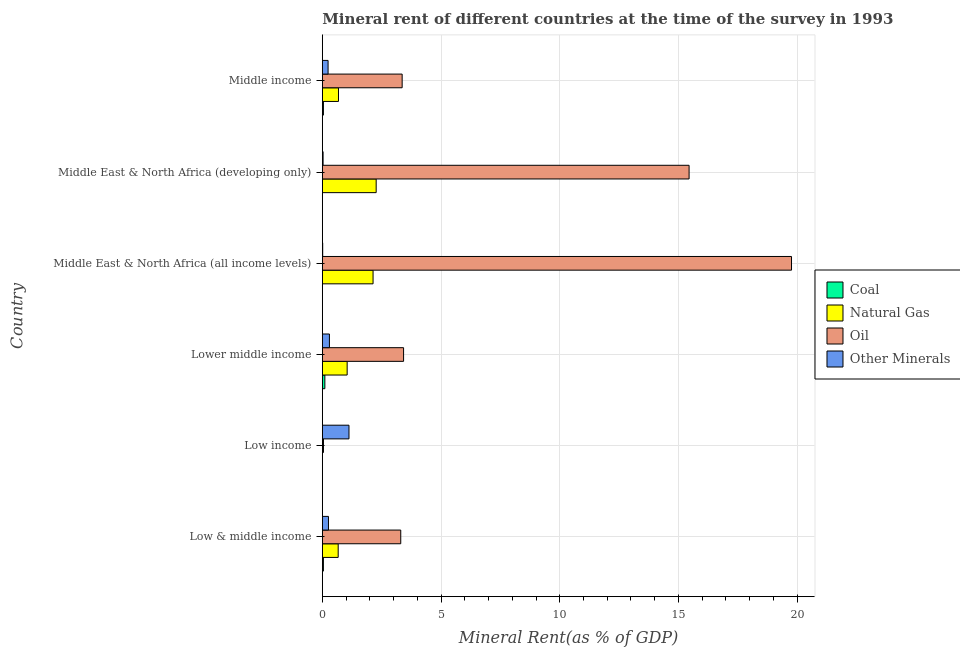How many different coloured bars are there?
Keep it short and to the point. 4. Are the number of bars on each tick of the Y-axis equal?
Give a very brief answer. Yes. How many bars are there on the 4th tick from the top?
Ensure brevity in your answer.  4. What is the label of the 1st group of bars from the top?
Give a very brief answer. Middle income. What is the  rent of other minerals in Middle East & North Africa (developing only)?
Your answer should be compact. 0.03. Across all countries, what is the maximum natural gas rent?
Ensure brevity in your answer.  2.27. Across all countries, what is the minimum oil rent?
Your response must be concise. 0.05. What is the total  rent of other minerals in the graph?
Give a very brief answer. 1.97. What is the difference between the natural gas rent in Low & middle income and that in Low income?
Provide a short and direct response. 0.67. What is the difference between the natural gas rent in Middle income and the  rent of other minerals in Low & middle income?
Your answer should be very brief. 0.42. What is the average natural gas rent per country?
Give a very brief answer. 1.13. What is the difference between the oil rent and natural gas rent in Low income?
Provide a succinct answer. 0.05. In how many countries, is the oil rent greater than 9 %?
Offer a terse response. 2. What is the ratio of the coal rent in Low & middle income to that in Middle East & North Africa (all income levels)?
Your response must be concise. 78.76. Is the coal rent in Lower middle income less than that in Middle East & North Africa (developing only)?
Give a very brief answer. No. Is the difference between the coal rent in Middle East & North Africa (all income levels) and Middle East & North Africa (developing only) greater than the difference between the oil rent in Middle East & North Africa (all income levels) and Middle East & North Africa (developing only)?
Make the answer very short. No. What is the difference between the highest and the second highest oil rent?
Keep it short and to the point. 4.31. What is the difference between the highest and the lowest  rent of other minerals?
Your answer should be very brief. 1.11. What does the 4th bar from the top in Low & middle income represents?
Make the answer very short. Coal. What does the 4th bar from the bottom in Middle East & North Africa (developing only) represents?
Make the answer very short. Other Minerals. Is it the case that in every country, the sum of the coal rent and natural gas rent is greater than the oil rent?
Offer a very short reply. No. How many bars are there?
Provide a short and direct response. 24. Are all the bars in the graph horizontal?
Provide a succinct answer. Yes. What is the difference between two consecutive major ticks on the X-axis?
Make the answer very short. 5. Are the values on the major ticks of X-axis written in scientific E-notation?
Provide a succinct answer. No. Does the graph contain any zero values?
Your answer should be very brief. No. How many legend labels are there?
Provide a succinct answer. 4. What is the title of the graph?
Keep it short and to the point. Mineral rent of different countries at the time of the survey in 1993. What is the label or title of the X-axis?
Offer a terse response. Mineral Rent(as % of GDP). What is the Mineral Rent(as % of GDP) of Coal in Low & middle income?
Offer a terse response. 0.05. What is the Mineral Rent(as % of GDP) of Natural Gas in Low & middle income?
Offer a terse response. 0.67. What is the Mineral Rent(as % of GDP) of Oil in Low & middle income?
Provide a succinct answer. 3.3. What is the Mineral Rent(as % of GDP) in Other Minerals in Low & middle income?
Offer a terse response. 0.26. What is the Mineral Rent(as % of GDP) in Coal in Low income?
Your response must be concise. 8.23532495624202e-6. What is the Mineral Rent(as % of GDP) of Natural Gas in Low income?
Ensure brevity in your answer.  1.98169078129084e-5. What is the Mineral Rent(as % of GDP) in Oil in Low income?
Keep it short and to the point. 0.05. What is the Mineral Rent(as % of GDP) of Other Minerals in Low income?
Make the answer very short. 1.12. What is the Mineral Rent(as % of GDP) of Coal in Lower middle income?
Ensure brevity in your answer.  0.11. What is the Mineral Rent(as % of GDP) in Natural Gas in Lower middle income?
Provide a short and direct response. 1.05. What is the Mineral Rent(as % of GDP) in Oil in Lower middle income?
Give a very brief answer. 3.42. What is the Mineral Rent(as % of GDP) of Other Minerals in Lower middle income?
Give a very brief answer. 0.3. What is the Mineral Rent(as % of GDP) in Coal in Middle East & North Africa (all income levels)?
Offer a terse response. 0. What is the Mineral Rent(as % of GDP) in Natural Gas in Middle East & North Africa (all income levels)?
Your answer should be compact. 2.14. What is the Mineral Rent(as % of GDP) of Oil in Middle East & North Africa (all income levels)?
Offer a very short reply. 19.76. What is the Mineral Rent(as % of GDP) of Other Minerals in Middle East & North Africa (all income levels)?
Your answer should be very brief. 0.02. What is the Mineral Rent(as % of GDP) in Coal in Middle East & North Africa (developing only)?
Ensure brevity in your answer.  0. What is the Mineral Rent(as % of GDP) in Natural Gas in Middle East & North Africa (developing only)?
Offer a very short reply. 2.27. What is the Mineral Rent(as % of GDP) in Oil in Middle East & North Africa (developing only)?
Provide a succinct answer. 15.45. What is the Mineral Rent(as % of GDP) in Other Minerals in Middle East & North Africa (developing only)?
Give a very brief answer. 0.03. What is the Mineral Rent(as % of GDP) of Coal in Middle income?
Your answer should be compact. 0.05. What is the Mineral Rent(as % of GDP) in Natural Gas in Middle income?
Give a very brief answer. 0.68. What is the Mineral Rent(as % of GDP) in Oil in Middle income?
Ensure brevity in your answer.  3.36. What is the Mineral Rent(as % of GDP) in Other Minerals in Middle income?
Your answer should be compact. 0.24. Across all countries, what is the maximum Mineral Rent(as % of GDP) of Coal?
Offer a very short reply. 0.11. Across all countries, what is the maximum Mineral Rent(as % of GDP) of Natural Gas?
Provide a succinct answer. 2.27. Across all countries, what is the maximum Mineral Rent(as % of GDP) of Oil?
Offer a terse response. 19.76. Across all countries, what is the maximum Mineral Rent(as % of GDP) of Other Minerals?
Offer a terse response. 1.12. Across all countries, what is the minimum Mineral Rent(as % of GDP) of Coal?
Offer a terse response. 8.23532495624202e-6. Across all countries, what is the minimum Mineral Rent(as % of GDP) of Natural Gas?
Your answer should be very brief. 1.98169078129084e-5. Across all countries, what is the minimum Mineral Rent(as % of GDP) in Oil?
Provide a succinct answer. 0.05. Across all countries, what is the minimum Mineral Rent(as % of GDP) of Other Minerals?
Give a very brief answer. 0.02. What is the total Mineral Rent(as % of GDP) in Coal in the graph?
Offer a very short reply. 0.2. What is the total Mineral Rent(as % of GDP) in Natural Gas in the graph?
Make the answer very short. 6.8. What is the total Mineral Rent(as % of GDP) of Oil in the graph?
Offer a terse response. 45.35. What is the total Mineral Rent(as % of GDP) in Other Minerals in the graph?
Your response must be concise. 1.97. What is the difference between the Mineral Rent(as % of GDP) in Coal in Low & middle income and that in Low income?
Ensure brevity in your answer.  0.05. What is the difference between the Mineral Rent(as % of GDP) of Natural Gas in Low & middle income and that in Low income?
Your answer should be very brief. 0.67. What is the difference between the Mineral Rent(as % of GDP) of Oil in Low & middle income and that in Low income?
Make the answer very short. 3.25. What is the difference between the Mineral Rent(as % of GDP) in Other Minerals in Low & middle income and that in Low income?
Give a very brief answer. -0.86. What is the difference between the Mineral Rent(as % of GDP) of Coal in Low & middle income and that in Lower middle income?
Your response must be concise. -0.06. What is the difference between the Mineral Rent(as % of GDP) of Natural Gas in Low & middle income and that in Lower middle income?
Ensure brevity in your answer.  -0.38. What is the difference between the Mineral Rent(as % of GDP) of Oil in Low & middle income and that in Lower middle income?
Your answer should be very brief. -0.12. What is the difference between the Mineral Rent(as % of GDP) in Other Minerals in Low & middle income and that in Lower middle income?
Make the answer very short. -0.04. What is the difference between the Mineral Rent(as % of GDP) in Coal in Low & middle income and that in Middle East & North Africa (all income levels)?
Give a very brief answer. 0.04. What is the difference between the Mineral Rent(as % of GDP) of Natural Gas in Low & middle income and that in Middle East & North Africa (all income levels)?
Provide a succinct answer. -1.47. What is the difference between the Mineral Rent(as % of GDP) in Oil in Low & middle income and that in Middle East & North Africa (all income levels)?
Make the answer very short. -16.46. What is the difference between the Mineral Rent(as % of GDP) of Other Minerals in Low & middle income and that in Middle East & North Africa (all income levels)?
Your answer should be very brief. 0.24. What is the difference between the Mineral Rent(as % of GDP) in Coal in Low & middle income and that in Middle East & North Africa (developing only)?
Provide a short and direct response. 0.04. What is the difference between the Mineral Rent(as % of GDP) of Natural Gas in Low & middle income and that in Middle East & North Africa (developing only)?
Provide a succinct answer. -1.6. What is the difference between the Mineral Rent(as % of GDP) in Oil in Low & middle income and that in Middle East & North Africa (developing only)?
Provide a short and direct response. -12.14. What is the difference between the Mineral Rent(as % of GDP) in Other Minerals in Low & middle income and that in Middle East & North Africa (developing only)?
Your response must be concise. 0.23. What is the difference between the Mineral Rent(as % of GDP) of Coal in Low & middle income and that in Middle income?
Provide a short and direct response. -0. What is the difference between the Mineral Rent(as % of GDP) in Natural Gas in Low & middle income and that in Middle income?
Keep it short and to the point. -0.01. What is the difference between the Mineral Rent(as % of GDP) in Oil in Low & middle income and that in Middle income?
Provide a short and direct response. -0.06. What is the difference between the Mineral Rent(as % of GDP) of Other Minerals in Low & middle income and that in Middle income?
Provide a short and direct response. 0.02. What is the difference between the Mineral Rent(as % of GDP) in Coal in Low income and that in Lower middle income?
Your answer should be compact. -0.11. What is the difference between the Mineral Rent(as % of GDP) of Natural Gas in Low income and that in Lower middle income?
Provide a succinct answer. -1.05. What is the difference between the Mineral Rent(as % of GDP) in Oil in Low income and that in Lower middle income?
Provide a short and direct response. -3.37. What is the difference between the Mineral Rent(as % of GDP) in Other Minerals in Low income and that in Lower middle income?
Your response must be concise. 0.82. What is the difference between the Mineral Rent(as % of GDP) of Coal in Low income and that in Middle East & North Africa (all income levels)?
Give a very brief answer. -0. What is the difference between the Mineral Rent(as % of GDP) of Natural Gas in Low income and that in Middle East & North Africa (all income levels)?
Keep it short and to the point. -2.14. What is the difference between the Mineral Rent(as % of GDP) in Oil in Low income and that in Middle East & North Africa (all income levels)?
Provide a short and direct response. -19.71. What is the difference between the Mineral Rent(as % of GDP) in Other Minerals in Low income and that in Middle East & North Africa (all income levels)?
Provide a short and direct response. 1.11. What is the difference between the Mineral Rent(as % of GDP) in Coal in Low income and that in Middle East & North Africa (developing only)?
Keep it short and to the point. -0. What is the difference between the Mineral Rent(as % of GDP) in Natural Gas in Low income and that in Middle East & North Africa (developing only)?
Your response must be concise. -2.27. What is the difference between the Mineral Rent(as % of GDP) of Oil in Low income and that in Middle East & North Africa (developing only)?
Provide a short and direct response. -15.4. What is the difference between the Mineral Rent(as % of GDP) of Other Minerals in Low income and that in Middle East & North Africa (developing only)?
Ensure brevity in your answer.  1.09. What is the difference between the Mineral Rent(as % of GDP) of Coal in Low income and that in Middle income?
Your response must be concise. -0.05. What is the difference between the Mineral Rent(as % of GDP) of Natural Gas in Low income and that in Middle income?
Keep it short and to the point. -0.68. What is the difference between the Mineral Rent(as % of GDP) of Oil in Low income and that in Middle income?
Your answer should be compact. -3.31. What is the difference between the Mineral Rent(as % of GDP) of Other Minerals in Low income and that in Middle income?
Offer a terse response. 0.88. What is the difference between the Mineral Rent(as % of GDP) in Coal in Lower middle income and that in Middle East & North Africa (all income levels)?
Your answer should be very brief. 0.11. What is the difference between the Mineral Rent(as % of GDP) in Natural Gas in Lower middle income and that in Middle East & North Africa (all income levels)?
Provide a succinct answer. -1.09. What is the difference between the Mineral Rent(as % of GDP) in Oil in Lower middle income and that in Middle East & North Africa (all income levels)?
Make the answer very short. -16.34. What is the difference between the Mineral Rent(as % of GDP) in Other Minerals in Lower middle income and that in Middle East & North Africa (all income levels)?
Offer a terse response. 0.28. What is the difference between the Mineral Rent(as % of GDP) in Coal in Lower middle income and that in Middle East & North Africa (developing only)?
Offer a very short reply. 0.11. What is the difference between the Mineral Rent(as % of GDP) of Natural Gas in Lower middle income and that in Middle East & North Africa (developing only)?
Provide a succinct answer. -1.22. What is the difference between the Mineral Rent(as % of GDP) of Oil in Lower middle income and that in Middle East & North Africa (developing only)?
Your answer should be very brief. -12.03. What is the difference between the Mineral Rent(as % of GDP) of Other Minerals in Lower middle income and that in Middle East & North Africa (developing only)?
Your answer should be compact. 0.27. What is the difference between the Mineral Rent(as % of GDP) in Coal in Lower middle income and that in Middle income?
Provide a short and direct response. 0.06. What is the difference between the Mineral Rent(as % of GDP) of Natural Gas in Lower middle income and that in Middle income?
Your response must be concise. 0.37. What is the difference between the Mineral Rent(as % of GDP) of Oil in Lower middle income and that in Middle income?
Make the answer very short. 0.06. What is the difference between the Mineral Rent(as % of GDP) in Other Minerals in Lower middle income and that in Middle income?
Give a very brief answer. 0.06. What is the difference between the Mineral Rent(as % of GDP) in Coal in Middle East & North Africa (all income levels) and that in Middle East & North Africa (developing only)?
Make the answer very short. -0. What is the difference between the Mineral Rent(as % of GDP) of Natural Gas in Middle East & North Africa (all income levels) and that in Middle East & North Africa (developing only)?
Keep it short and to the point. -0.13. What is the difference between the Mineral Rent(as % of GDP) in Oil in Middle East & North Africa (all income levels) and that in Middle East & North Africa (developing only)?
Offer a very short reply. 4.31. What is the difference between the Mineral Rent(as % of GDP) in Other Minerals in Middle East & North Africa (all income levels) and that in Middle East & North Africa (developing only)?
Give a very brief answer. -0.02. What is the difference between the Mineral Rent(as % of GDP) in Coal in Middle East & North Africa (all income levels) and that in Middle income?
Offer a very short reply. -0.05. What is the difference between the Mineral Rent(as % of GDP) in Natural Gas in Middle East & North Africa (all income levels) and that in Middle income?
Ensure brevity in your answer.  1.46. What is the difference between the Mineral Rent(as % of GDP) of Oil in Middle East & North Africa (all income levels) and that in Middle income?
Offer a very short reply. 16.4. What is the difference between the Mineral Rent(as % of GDP) in Other Minerals in Middle East & North Africa (all income levels) and that in Middle income?
Your response must be concise. -0.23. What is the difference between the Mineral Rent(as % of GDP) of Coal in Middle East & North Africa (developing only) and that in Middle income?
Offer a terse response. -0.04. What is the difference between the Mineral Rent(as % of GDP) of Natural Gas in Middle East & North Africa (developing only) and that in Middle income?
Your answer should be very brief. 1.59. What is the difference between the Mineral Rent(as % of GDP) of Oil in Middle East & North Africa (developing only) and that in Middle income?
Offer a terse response. 12.09. What is the difference between the Mineral Rent(as % of GDP) of Other Minerals in Middle East & North Africa (developing only) and that in Middle income?
Ensure brevity in your answer.  -0.21. What is the difference between the Mineral Rent(as % of GDP) of Coal in Low & middle income and the Mineral Rent(as % of GDP) of Natural Gas in Low income?
Ensure brevity in your answer.  0.05. What is the difference between the Mineral Rent(as % of GDP) in Coal in Low & middle income and the Mineral Rent(as % of GDP) in Oil in Low income?
Your response must be concise. -0. What is the difference between the Mineral Rent(as % of GDP) of Coal in Low & middle income and the Mineral Rent(as % of GDP) of Other Minerals in Low income?
Ensure brevity in your answer.  -1.08. What is the difference between the Mineral Rent(as % of GDP) in Natural Gas in Low & middle income and the Mineral Rent(as % of GDP) in Oil in Low income?
Ensure brevity in your answer.  0.62. What is the difference between the Mineral Rent(as % of GDP) of Natural Gas in Low & middle income and the Mineral Rent(as % of GDP) of Other Minerals in Low income?
Make the answer very short. -0.46. What is the difference between the Mineral Rent(as % of GDP) of Oil in Low & middle income and the Mineral Rent(as % of GDP) of Other Minerals in Low income?
Provide a succinct answer. 2.18. What is the difference between the Mineral Rent(as % of GDP) of Coal in Low & middle income and the Mineral Rent(as % of GDP) of Natural Gas in Lower middle income?
Make the answer very short. -1. What is the difference between the Mineral Rent(as % of GDP) of Coal in Low & middle income and the Mineral Rent(as % of GDP) of Oil in Lower middle income?
Offer a very short reply. -3.38. What is the difference between the Mineral Rent(as % of GDP) in Coal in Low & middle income and the Mineral Rent(as % of GDP) in Other Minerals in Lower middle income?
Keep it short and to the point. -0.25. What is the difference between the Mineral Rent(as % of GDP) in Natural Gas in Low & middle income and the Mineral Rent(as % of GDP) in Oil in Lower middle income?
Provide a short and direct response. -2.75. What is the difference between the Mineral Rent(as % of GDP) in Natural Gas in Low & middle income and the Mineral Rent(as % of GDP) in Other Minerals in Lower middle income?
Your answer should be compact. 0.37. What is the difference between the Mineral Rent(as % of GDP) of Oil in Low & middle income and the Mineral Rent(as % of GDP) of Other Minerals in Lower middle income?
Provide a succinct answer. 3. What is the difference between the Mineral Rent(as % of GDP) in Coal in Low & middle income and the Mineral Rent(as % of GDP) in Natural Gas in Middle East & North Africa (all income levels)?
Give a very brief answer. -2.09. What is the difference between the Mineral Rent(as % of GDP) in Coal in Low & middle income and the Mineral Rent(as % of GDP) in Oil in Middle East & North Africa (all income levels)?
Make the answer very short. -19.72. What is the difference between the Mineral Rent(as % of GDP) in Coal in Low & middle income and the Mineral Rent(as % of GDP) in Other Minerals in Middle East & North Africa (all income levels)?
Make the answer very short. 0.03. What is the difference between the Mineral Rent(as % of GDP) in Natural Gas in Low & middle income and the Mineral Rent(as % of GDP) in Oil in Middle East & North Africa (all income levels)?
Your answer should be very brief. -19.09. What is the difference between the Mineral Rent(as % of GDP) of Natural Gas in Low & middle income and the Mineral Rent(as % of GDP) of Other Minerals in Middle East & North Africa (all income levels)?
Offer a very short reply. 0.65. What is the difference between the Mineral Rent(as % of GDP) in Oil in Low & middle income and the Mineral Rent(as % of GDP) in Other Minerals in Middle East & North Africa (all income levels)?
Provide a short and direct response. 3.29. What is the difference between the Mineral Rent(as % of GDP) of Coal in Low & middle income and the Mineral Rent(as % of GDP) of Natural Gas in Middle East & North Africa (developing only)?
Provide a succinct answer. -2.22. What is the difference between the Mineral Rent(as % of GDP) of Coal in Low & middle income and the Mineral Rent(as % of GDP) of Oil in Middle East & North Africa (developing only)?
Your answer should be very brief. -15.4. What is the difference between the Mineral Rent(as % of GDP) in Coal in Low & middle income and the Mineral Rent(as % of GDP) in Other Minerals in Middle East & North Africa (developing only)?
Make the answer very short. 0.01. What is the difference between the Mineral Rent(as % of GDP) of Natural Gas in Low & middle income and the Mineral Rent(as % of GDP) of Oil in Middle East & North Africa (developing only)?
Provide a succinct answer. -14.78. What is the difference between the Mineral Rent(as % of GDP) in Natural Gas in Low & middle income and the Mineral Rent(as % of GDP) in Other Minerals in Middle East & North Africa (developing only)?
Provide a short and direct response. 0.64. What is the difference between the Mineral Rent(as % of GDP) of Oil in Low & middle income and the Mineral Rent(as % of GDP) of Other Minerals in Middle East & North Africa (developing only)?
Ensure brevity in your answer.  3.27. What is the difference between the Mineral Rent(as % of GDP) in Coal in Low & middle income and the Mineral Rent(as % of GDP) in Natural Gas in Middle income?
Give a very brief answer. -0.63. What is the difference between the Mineral Rent(as % of GDP) of Coal in Low & middle income and the Mineral Rent(as % of GDP) of Oil in Middle income?
Your response must be concise. -3.32. What is the difference between the Mineral Rent(as % of GDP) of Coal in Low & middle income and the Mineral Rent(as % of GDP) of Other Minerals in Middle income?
Ensure brevity in your answer.  -0.2. What is the difference between the Mineral Rent(as % of GDP) in Natural Gas in Low & middle income and the Mineral Rent(as % of GDP) in Oil in Middle income?
Keep it short and to the point. -2.69. What is the difference between the Mineral Rent(as % of GDP) of Natural Gas in Low & middle income and the Mineral Rent(as % of GDP) of Other Minerals in Middle income?
Ensure brevity in your answer.  0.43. What is the difference between the Mineral Rent(as % of GDP) of Oil in Low & middle income and the Mineral Rent(as % of GDP) of Other Minerals in Middle income?
Your response must be concise. 3.06. What is the difference between the Mineral Rent(as % of GDP) of Coal in Low income and the Mineral Rent(as % of GDP) of Natural Gas in Lower middle income?
Your answer should be compact. -1.05. What is the difference between the Mineral Rent(as % of GDP) of Coal in Low income and the Mineral Rent(as % of GDP) of Oil in Lower middle income?
Offer a terse response. -3.42. What is the difference between the Mineral Rent(as % of GDP) in Coal in Low income and the Mineral Rent(as % of GDP) in Other Minerals in Lower middle income?
Ensure brevity in your answer.  -0.3. What is the difference between the Mineral Rent(as % of GDP) in Natural Gas in Low income and the Mineral Rent(as % of GDP) in Oil in Lower middle income?
Keep it short and to the point. -3.42. What is the difference between the Mineral Rent(as % of GDP) of Natural Gas in Low income and the Mineral Rent(as % of GDP) of Other Minerals in Lower middle income?
Provide a short and direct response. -0.3. What is the difference between the Mineral Rent(as % of GDP) in Oil in Low income and the Mineral Rent(as % of GDP) in Other Minerals in Lower middle income?
Your answer should be very brief. -0.25. What is the difference between the Mineral Rent(as % of GDP) of Coal in Low income and the Mineral Rent(as % of GDP) of Natural Gas in Middle East & North Africa (all income levels)?
Ensure brevity in your answer.  -2.14. What is the difference between the Mineral Rent(as % of GDP) in Coal in Low income and the Mineral Rent(as % of GDP) in Oil in Middle East & North Africa (all income levels)?
Offer a terse response. -19.76. What is the difference between the Mineral Rent(as % of GDP) in Coal in Low income and the Mineral Rent(as % of GDP) in Other Minerals in Middle East & North Africa (all income levels)?
Your answer should be compact. -0.02. What is the difference between the Mineral Rent(as % of GDP) of Natural Gas in Low income and the Mineral Rent(as % of GDP) of Oil in Middle East & North Africa (all income levels)?
Provide a short and direct response. -19.76. What is the difference between the Mineral Rent(as % of GDP) of Natural Gas in Low income and the Mineral Rent(as % of GDP) of Other Minerals in Middle East & North Africa (all income levels)?
Offer a very short reply. -0.02. What is the difference between the Mineral Rent(as % of GDP) of Oil in Low income and the Mineral Rent(as % of GDP) of Other Minerals in Middle East & North Africa (all income levels)?
Offer a very short reply. 0.03. What is the difference between the Mineral Rent(as % of GDP) of Coal in Low income and the Mineral Rent(as % of GDP) of Natural Gas in Middle East & North Africa (developing only)?
Give a very brief answer. -2.27. What is the difference between the Mineral Rent(as % of GDP) of Coal in Low income and the Mineral Rent(as % of GDP) of Oil in Middle East & North Africa (developing only)?
Your answer should be compact. -15.45. What is the difference between the Mineral Rent(as % of GDP) of Coal in Low income and the Mineral Rent(as % of GDP) of Other Minerals in Middle East & North Africa (developing only)?
Offer a very short reply. -0.03. What is the difference between the Mineral Rent(as % of GDP) in Natural Gas in Low income and the Mineral Rent(as % of GDP) in Oil in Middle East & North Africa (developing only)?
Make the answer very short. -15.45. What is the difference between the Mineral Rent(as % of GDP) in Natural Gas in Low income and the Mineral Rent(as % of GDP) in Other Minerals in Middle East & North Africa (developing only)?
Offer a very short reply. -0.03. What is the difference between the Mineral Rent(as % of GDP) of Oil in Low income and the Mineral Rent(as % of GDP) of Other Minerals in Middle East & North Africa (developing only)?
Your answer should be very brief. 0.02. What is the difference between the Mineral Rent(as % of GDP) in Coal in Low income and the Mineral Rent(as % of GDP) in Natural Gas in Middle income?
Your answer should be very brief. -0.68. What is the difference between the Mineral Rent(as % of GDP) of Coal in Low income and the Mineral Rent(as % of GDP) of Oil in Middle income?
Give a very brief answer. -3.36. What is the difference between the Mineral Rent(as % of GDP) of Coal in Low income and the Mineral Rent(as % of GDP) of Other Minerals in Middle income?
Offer a terse response. -0.24. What is the difference between the Mineral Rent(as % of GDP) in Natural Gas in Low income and the Mineral Rent(as % of GDP) in Oil in Middle income?
Ensure brevity in your answer.  -3.36. What is the difference between the Mineral Rent(as % of GDP) of Natural Gas in Low income and the Mineral Rent(as % of GDP) of Other Minerals in Middle income?
Offer a terse response. -0.24. What is the difference between the Mineral Rent(as % of GDP) of Oil in Low income and the Mineral Rent(as % of GDP) of Other Minerals in Middle income?
Provide a succinct answer. -0.19. What is the difference between the Mineral Rent(as % of GDP) of Coal in Lower middle income and the Mineral Rent(as % of GDP) of Natural Gas in Middle East & North Africa (all income levels)?
Offer a very short reply. -2.03. What is the difference between the Mineral Rent(as % of GDP) in Coal in Lower middle income and the Mineral Rent(as % of GDP) in Oil in Middle East & North Africa (all income levels)?
Offer a terse response. -19.66. What is the difference between the Mineral Rent(as % of GDP) of Coal in Lower middle income and the Mineral Rent(as % of GDP) of Other Minerals in Middle East & North Africa (all income levels)?
Give a very brief answer. 0.09. What is the difference between the Mineral Rent(as % of GDP) of Natural Gas in Lower middle income and the Mineral Rent(as % of GDP) of Oil in Middle East & North Africa (all income levels)?
Offer a very short reply. -18.72. What is the difference between the Mineral Rent(as % of GDP) of Natural Gas in Lower middle income and the Mineral Rent(as % of GDP) of Other Minerals in Middle East & North Africa (all income levels)?
Provide a succinct answer. 1.03. What is the difference between the Mineral Rent(as % of GDP) of Oil in Lower middle income and the Mineral Rent(as % of GDP) of Other Minerals in Middle East & North Africa (all income levels)?
Offer a terse response. 3.41. What is the difference between the Mineral Rent(as % of GDP) in Coal in Lower middle income and the Mineral Rent(as % of GDP) in Natural Gas in Middle East & North Africa (developing only)?
Make the answer very short. -2.16. What is the difference between the Mineral Rent(as % of GDP) in Coal in Lower middle income and the Mineral Rent(as % of GDP) in Oil in Middle East & North Africa (developing only)?
Provide a succinct answer. -15.34. What is the difference between the Mineral Rent(as % of GDP) in Coal in Lower middle income and the Mineral Rent(as % of GDP) in Other Minerals in Middle East & North Africa (developing only)?
Ensure brevity in your answer.  0.07. What is the difference between the Mineral Rent(as % of GDP) of Natural Gas in Lower middle income and the Mineral Rent(as % of GDP) of Oil in Middle East & North Africa (developing only)?
Make the answer very short. -14.4. What is the difference between the Mineral Rent(as % of GDP) in Natural Gas in Lower middle income and the Mineral Rent(as % of GDP) in Other Minerals in Middle East & North Africa (developing only)?
Provide a succinct answer. 1.01. What is the difference between the Mineral Rent(as % of GDP) of Oil in Lower middle income and the Mineral Rent(as % of GDP) of Other Minerals in Middle East & North Africa (developing only)?
Offer a very short reply. 3.39. What is the difference between the Mineral Rent(as % of GDP) of Coal in Lower middle income and the Mineral Rent(as % of GDP) of Natural Gas in Middle income?
Your response must be concise. -0.57. What is the difference between the Mineral Rent(as % of GDP) of Coal in Lower middle income and the Mineral Rent(as % of GDP) of Oil in Middle income?
Provide a succinct answer. -3.26. What is the difference between the Mineral Rent(as % of GDP) in Coal in Lower middle income and the Mineral Rent(as % of GDP) in Other Minerals in Middle income?
Provide a succinct answer. -0.14. What is the difference between the Mineral Rent(as % of GDP) of Natural Gas in Lower middle income and the Mineral Rent(as % of GDP) of Oil in Middle income?
Offer a terse response. -2.32. What is the difference between the Mineral Rent(as % of GDP) in Natural Gas in Lower middle income and the Mineral Rent(as % of GDP) in Other Minerals in Middle income?
Offer a very short reply. 0.8. What is the difference between the Mineral Rent(as % of GDP) in Oil in Lower middle income and the Mineral Rent(as % of GDP) in Other Minerals in Middle income?
Ensure brevity in your answer.  3.18. What is the difference between the Mineral Rent(as % of GDP) of Coal in Middle East & North Africa (all income levels) and the Mineral Rent(as % of GDP) of Natural Gas in Middle East & North Africa (developing only)?
Keep it short and to the point. -2.27. What is the difference between the Mineral Rent(as % of GDP) in Coal in Middle East & North Africa (all income levels) and the Mineral Rent(as % of GDP) in Oil in Middle East & North Africa (developing only)?
Your response must be concise. -15.45. What is the difference between the Mineral Rent(as % of GDP) in Coal in Middle East & North Africa (all income levels) and the Mineral Rent(as % of GDP) in Other Minerals in Middle East & North Africa (developing only)?
Your response must be concise. -0.03. What is the difference between the Mineral Rent(as % of GDP) in Natural Gas in Middle East & North Africa (all income levels) and the Mineral Rent(as % of GDP) in Oil in Middle East & North Africa (developing only)?
Your answer should be very brief. -13.31. What is the difference between the Mineral Rent(as % of GDP) in Natural Gas in Middle East & North Africa (all income levels) and the Mineral Rent(as % of GDP) in Other Minerals in Middle East & North Africa (developing only)?
Provide a short and direct response. 2.11. What is the difference between the Mineral Rent(as % of GDP) in Oil in Middle East & North Africa (all income levels) and the Mineral Rent(as % of GDP) in Other Minerals in Middle East & North Africa (developing only)?
Keep it short and to the point. 19.73. What is the difference between the Mineral Rent(as % of GDP) in Coal in Middle East & North Africa (all income levels) and the Mineral Rent(as % of GDP) in Natural Gas in Middle income?
Your response must be concise. -0.68. What is the difference between the Mineral Rent(as % of GDP) of Coal in Middle East & North Africa (all income levels) and the Mineral Rent(as % of GDP) of Oil in Middle income?
Your response must be concise. -3.36. What is the difference between the Mineral Rent(as % of GDP) in Coal in Middle East & North Africa (all income levels) and the Mineral Rent(as % of GDP) in Other Minerals in Middle income?
Provide a succinct answer. -0.24. What is the difference between the Mineral Rent(as % of GDP) of Natural Gas in Middle East & North Africa (all income levels) and the Mineral Rent(as % of GDP) of Oil in Middle income?
Your answer should be very brief. -1.23. What is the difference between the Mineral Rent(as % of GDP) of Natural Gas in Middle East & North Africa (all income levels) and the Mineral Rent(as % of GDP) of Other Minerals in Middle income?
Your answer should be very brief. 1.89. What is the difference between the Mineral Rent(as % of GDP) of Oil in Middle East & North Africa (all income levels) and the Mineral Rent(as % of GDP) of Other Minerals in Middle income?
Your response must be concise. 19.52. What is the difference between the Mineral Rent(as % of GDP) in Coal in Middle East & North Africa (developing only) and the Mineral Rent(as % of GDP) in Natural Gas in Middle income?
Provide a succinct answer. -0.68. What is the difference between the Mineral Rent(as % of GDP) in Coal in Middle East & North Africa (developing only) and the Mineral Rent(as % of GDP) in Oil in Middle income?
Offer a terse response. -3.36. What is the difference between the Mineral Rent(as % of GDP) in Coal in Middle East & North Africa (developing only) and the Mineral Rent(as % of GDP) in Other Minerals in Middle income?
Your answer should be compact. -0.24. What is the difference between the Mineral Rent(as % of GDP) in Natural Gas in Middle East & North Africa (developing only) and the Mineral Rent(as % of GDP) in Oil in Middle income?
Your answer should be compact. -1.09. What is the difference between the Mineral Rent(as % of GDP) in Natural Gas in Middle East & North Africa (developing only) and the Mineral Rent(as % of GDP) in Other Minerals in Middle income?
Make the answer very short. 2.03. What is the difference between the Mineral Rent(as % of GDP) of Oil in Middle East & North Africa (developing only) and the Mineral Rent(as % of GDP) of Other Minerals in Middle income?
Give a very brief answer. 15.21. What is the average Mineral Rent(as % of GDP) of Coal per country?
Your response must be concise. 0.03. What is the average Mineral Rent(as % of GDP) of Natural Gas per country?
Give a very brief answer. 1.13. What is the average Mineral Rent(as % of GDP) in Oil per country?
Ensure brevity in your answer.  7.56. What is the average Mineral Rent(as % of GDP) of Other Minerals per country?
Provide a succinct answer. 0.33. What is the difference between the Mineral Rent(as % of GDP) in Coal and Mineral Rent(as % of GDP) in Natural Gas in Low & middle income?
Keep it short and to the point. -0.62. What is the difference between the Mineral Rent(as % of GDP) in Coal and Mineral Rent(as % of GDP) in Oil in Low & middle income?
Offer a terse response. -3.26. What is the difference between the Mineral Rent(as % of GDP) in Coal and Mineral Rent(as % of GDP) in Other Minerals in Low & middle income?
Your response must be concise. -0.21. What is the difference between the Mineral Rent(as % of GDP) in Natural Gas and Mineral Rent(as % of GDP) in Oil in Low & middle income?
Make the answer very short. -2.64. What is the difference between the Mineral Rent(as % of GDP) in Natural Gas and Mineral Rent(as % of GDP) in Other Minerals in Low & middle income?
Provide a short and direct response. 0.41. What is the difference between the Mineral Rent(as % of GDP) in Oil and Mineral Rent(as % of GDP) in Other Minerals in Low & middle income?
Your answer should be compact. 3.04. What is the difference between the Mineral Rent(as % of GDP) of Coal and Mineral Rent(as % of GDP) of Oil in Low income?
Give a very brief answer. -0.05. What is the difference between the Mineral Rent(as % of GDP) in Coal and Mineral Rent(as % of GDP) in Other Minerals in Low income?
Provide a short and direct response. -1.12. What is the difference between the Mineral Rent(as % of GDP) of Natural Gas and Mineral Rent(as % of GDP) of Oil in Low income?
Give a very brief answer. -0.05. What is the difference between the Mineral Rent(as % of GDP) of Natural Gas and Mineral Rent(as % of GDP) of Other Minerals in Low income?
Give a very brief answer. -1.12. What is the difference between the Mineral Rent(as % of GDP) in Oil and Mineral Rent(as % of GDP) in Other Minerals in Low income?
Your answer should be compact. -1.07. What is the difference between the Mineral Rent(as % of GDP) in Coal and Mineral Rent(as % of GDP) in Natural Gas in Lower middle income?
Make the answer very short. -0.94. What is the difference between the Mineral Rent(as % of GDP) of Coal and Mineral Rent(as % of GDP) of Oil in Lower middle income?
Your answer should be very brief. -3.32. What is the difference between the Mineral Rent(as % of GDP) in Coal and Mineral Rent(as % of GDP) in Other Minerals in Lower middle income?
Keep it short and to the point. -0.19. What is the difference between the Mineral Rent(as % of GDP) in Natural Gas and Mineral Rent(as % of GDP) in Oil in Lower middle income?
Give a very brief answer. -2.38. What is the difference between the Mineral Rent(as % of GDP) of Natural Gas and Mineral Rent(as % of GDP) of Other Minerals in Lower middle income?
Your answer should be very brief. 0.75. What is the difference between the Mineral Rent(as % of GDP) of Oil and Mineral Rent(as % of GDP) of Other Minerals in Lower middle income?
Provide a succinct answer. 3.12. What is the difference between the Mineral Rent(as % of GDP) of Coal and Mineral Rent(as % of GDP) of Natural Gas in Middle East & North Africa (all income levels)?
Your answer should be compact. -2.14. What is the difference between the Mineral Rent(as % of GDP) in Coal and Mineral Rent(as % of GDP) in Oil in Middle East & North Africa (all income levels)?
Keep it short and to the point. -19.76. What is the difference between the Mineral Rent(as % of GDP) in Coal and Mineral Rent(as % of GDP) in Other Minerals in Middle East & North Africa (all income levels)?
Give a very brief answer. -0.02. What is the difference between the Mineral Rent(as % of GDP) in Natural Gas and Mineral Rent(as % of GDP) in Oil in Middle East & North Africa (all income levels)?
Ensure brevity in your answer.  -17.63. What is the difference between the Mineral Rent(as % of GDP) of Natural Gas and Mineral Rent(as % of GDP) of Other Minerals in Middle East & North Africa (all income levels)?
Keep it short and to the point. 2.12. What is the difference between the Mineral Rent(as % of GDP) of Oil and Mineral Rent(as % of GDP) of Other Minerals in Middle East & North Africa (all income levels)?
Give a very brief answer. 19.75. What is the difference between the Mineral Rent(as % of GDP) in Coal and Mineral Rent(as % of GDP) in Natural Gas in Middle East & North Africa (developing only)?
Offer a very short reply. -2.27. What is the difference between the Mineral Rent(as % of GDP) in Coal and Mineral Rent(as % of GDP) in Oil in Middle East & North Africa (developing only)?
Provide a short and direct response. -15.45. What is the difference between the Mineral Rent(as % of GDP) of Coal and Mineral Rent(as % of GDP) of Other Minerals in Middle East & North Africa (developing only)?
Keep it short and to the point. -0.03. What is the difference between the Mineral Rent(as % of GDP) in Natural Gas and Mineral Rent(as % of GDP) in Oil in Middle East & North Africa (developing only)?
Make the answer very short. -13.18. What is the difference between the Mineral Rent(as % of GDP) in Natural Gas and Mineral Rent(as % of GDP) in Other Minerals in Middle East & North Africa (developing only)?
Your answer should be compact. 2.24. What is the difference between the Mineral Rent(as % of GDP) of Oil and Mineral Rent(as % of GDP) of Other Minerals in Middle East & North Africa (developing only)?
Your response must be concise. 15.42. What is the difference between the Mineral Rent(as % of GDP) in Coal and Mineral Rent(as % of GDP) in Natural Gas in Middle income?
Provide a short and direct response. -0.63. What is the difference between the Mineral Rent(as % of GDP) of Coal and Mineral Rent(as % of GDP) of Oil in Middle income?
Your answer should be very brief. -3.32. What is the difference between the Mineral Rent(as % of GDP) of Coal and Mineral Rent(as % of GDP) of Other Minerals in Middle income?
Make the answer very short. -0.2. What is the difference between the Mineral Rent(as % of GDP) of Natural Gas and Mineral Rent(as % of GDP) of Oil in Middle income?
Your response must be concise. -2.68. What is the difference between the Mineral Rent(as % of GDP) of Natural Gas and Mineral Rent(as % of GDP) of Other Minerals in Middle income?
Offer a very short reply. 0.44. What is the difference between the Mineral Rent(as % of GDP) in Oil and Mineral Rent(as % of GDP) in Other Minerals in Middle income?
Make the answer very short. 3.12. What is the ratio of the Mineral Rent(as % of GDP) of Coal in Low & middle income to that in Low income?
Make the answer very short. 5497.83. What is the ratio of the Mineral Rent(as % of GDP) in Natural Gas in Low & middle income to that in Low income?
Your answer should be very brief. 3.37e+04. What is the ratio of the Mineral Rent(as % of GDP) in Oil in Low & middle income to that in Low income?
Offer a terse response. 68.37. What is the ratio of the Mineral Rent(as % of GDP) in Other Minerals in Low & middle income to that in Low income?
Your answer should be very brief. 0.23. What is the ratio of the Mineral Rent(as % of GDP) in Coal in Low & middle income to that in Lower middle income?
Give a very brief answer. 0.43. What is the ratio of the Mineral Rent(as % of GDP) in Natural Gas in Low & middle income to that in Lower middle income?
Provide a succinct answer. 0.64. What is the ratio of the Mineral Rent(as % of GDP) in Oil in Low & middle income to that in Lower middle income?
Keep it short and to the point. 0.97. What is the ratio of the Mineral Rent(as % of GDP) in Other Minerals in Low & middle income to that in Lower middle income?
Keep it short and to the point. 0.87. What is the ratio of the Mineral Rent(as % of GDP) in Coal in Low & middle income to that in Middle East & North Africa (all income levels)?
Offer a terse response. 78.76. What is the ratio of the Mineral Rent(as % of GDP) in Natural Gas in Low & middle income to that in Middle East & North Africa (all income levels)?
Keep it short and to the point. 0.31. What is the ratio of the Mineral Rent(as % of GDP) of Oil in Low & middle income to that in Middle East & North Africa (all income levels)?
Provide a short and direct response. 0.17. What is the ratio of the Mineral Rent(as % of GDP) of Other Minerals in Low & middle income to that in Middle East & North Africa (all income levels)?
Give a very brief answer. 16.4. What is the ratio of the Mineral Rent(as % of GDP) in Coal in Low & middle income to that in Middle East & North Africa (developing only)?
Make the answer very short. 36.85. What is the ratio of the Mineral Rent(as % of GDP) in Natural Gas in Low & middle income to that in Middle East & North Africa (developing only)?
Your answer should be very brief. 0.29. What is the ratio of the Mineral Rent(as % of GDP) of Oil in Low & middle income to that in Middle East & North Africa (developing only)?
Provide a succinct answer. 0.21. What is the ratio of the Mineral Rent(as % of GDP) in Other Minerals in Low & middle income to that in Middle East & North Africa (developing only)?
Your answer should be compact. 8.08. What is the ratio of the Mineral Rent(as % of GDP) of Coal in Low & middle income to that in Middle income?
Offer a terse response. 0.98. What is the ratio of the Mineral Rent(as % of GDP) in Natural Gas in Low & middle income to that in Middle income?
Provide a short and direct response. 0.98. What is the ratio of the Mineral Rent(as % of GDP) in Oil in Low & middle income to that in Middle income?
Make the answer very short. 0.98. What is the ratio of the Mineral Rent(as % of GDP) of Other Minerals in Low & middle income to that in Middle income?
Ensure brevity in your answer.  1.07. What is the ratio of the Mineral Rent(as % of GDP) of Coal in Low income to that in Lower middle income?
Keep it short and to the point. 0. What is the ratio of the Mineral Rent(as % of GDP) in Natural Gas in Low income to that in Lower middle income?
Your answer should be very brief. 0. What is the ratio of the Mineral Rent(as % of GDP) in Oil in Low income to that in Lower middle income?
Make the answer very short. 0.01. What is the ratio of the Mineral Rent(as % of GDP) of Other Minerals in Low income to that in Lower middle income?
Provide a short and direct response. 3.76. What is the ratio of the Mineral Rent(as % of GDP) of Coal in Low income to that in Middle East & North Africa (all income levels)?
Offer a very short reply. 0.01. What is the ratio of the Mineral Rent(as % of GDP) of Natural Gas in Low income to that in Middle East & North Africa (all income levels)?
Offer a very short reply. 0. What is the ratio of the Mineral Rent(as % of GDP) in Oil in Low income to that in Middle East & North Africa (all income levels)?
Ensure brevity in your answer.  0. What is the ratio of the Mineral Rent(as % of GDP) in Other Minerals in Low income to that in Middle East & North Africa (all income levels)?
Offer a terse response. 71.23. What is the ratio of the Mineral Rent(as % of GDP) of Coal in Low income to that in Middle East & North Africa (developing only)?
Your response must be concise. 0.01. What is the ratio of the Mineral Rent(as % of GDP) in Natural Gas in Low income to that in Middle East & North Africa (developing only)?
Ensure brevity in your answer.  0. What is the ratio of the Mineral Rent(as % of GDP) in Oil in Low income to that in Middle East & North Africa (developing only)?
Your answer should be compact. 0. What is the ratio of the Mineral Rent(as % of GDP) of Other Minerals in Low income to that in Middle East & North Africa (developing only)?
Your answer should be very brief. 35.08. What is the ratio of the Mineral Rent(as % of GDP) of Natural Gas in Low income to that in Middle income?
Your answer should be very brief. 0. What is the ratio of the Mineral Rent(as % of GDP) in Oil in Low income to that in Middle income?
Provide a succinct answer. 0.01. What is the ratio of the Mineral Rent(as % of GDP) in Other Minerals in Low income to that in Middle income?
Make the answer very short. 4.63. What is the ratio of the Mineral Rent(as % of GDP) in Coal in Lower middle income to that in Middle East & North Africa (all income levels)?
Keep it short and to the point. 184.97. What is the ratio of the Mineral Rent(as % of GDP) in Natural Gas in Lower middle income to that in Middle East & North Africa (all income levels)?
Give a very brief answer. 0.49. What is the ratio of the Mineral Rent(as % of GDP) of Oil in Lower middle income to that in Middle East & North Africa (all income levels)?
Your answer should be very brief. 0.17. What is the ratio of the Mineral Rent(as % of GDP) of Other Minerals in Lower middle income to that in Middle East & North Africa (all income levels)?
Offer a terse response. 18.94. What is the ratio of the Mineral Rent(as % of GDP) of Coal in Lower middle income to that in Middle East & North Africa (developing only)?
Make the answer very short. 86.54. What is the ratio of the Mineral Rent(as % of GDP) in Natural Gas in Lower middle income to that in Middle East & North Africa (developing only)?
Offer a very short reply. 0.46. What is the ratio of the Mineral Rent(as % of GDP) of Oil in Lower middle income to that in Middle East & North Africa (developing only)?
Make the answer very short. 0.22. What is the ratio of the Mineral Rent(as % of GDP) in Other Minerals in Lower middle income to that in Middle East & North Africa (developing only)?
Offer a terse response. 9.33. What is the ratio of the Mineral Rent(as % of GDP) of Coal in Lower middle income to that in Middle income?
Give a very brief answer. 2.31. What is the ratio of the Mineral Rent(as % of GDP) in Natural Gas in Lower middle income to that in Middle income?
Give a very brief answer. 1.54. What is the ratio of the Mineral Rent(as % of GDP) of Oil in Lower middle income to that in Middle income?
Offer a very short reply. 1.02. What is the ratio of the Mineral Rent(as % of GDP) of Other Minerals in Lower middle income to that in Middle income?
Offer a terse response. 1.23. What is the ratio of the Mineral Rent(as % of GDP) of Coal in Middle East & North Africa (all income levels) to that in Middle East & North Africa (developing only)?
Make the answer very short. 0.47. What is the ratio of the Mineral Rent(as % of GDP) in Natural Gas in Middle East & North Africa (all income levels) to that in Middle East & North Africa (developing only)?
Make the answer very short. 0.94. What is the ratio of the Mineral Rent(as % of GDP) of Oil in Middle East & North Africa (all income levels) to that in Middle East & North Africa (developing only)?
Offer a very short reply. 1.28. What is the ratio of the Mineral Rent(as % of GDP) in Other Minerals in Middle East & North Africa (all income levels) to that in Middle East & North Africa (developing only)?
Provide a short and direct response. 0.49. What is the ratio of the Mineral Rent(as % of GDP) in Coal in Middle East & North Africa (all income levels) to that in Middle income?
Make the answer very short. 0.01. What is the ratio of the Mineral Rent(as % of GDP) in Natural Gas in Middle East & North Africa (all income levels) to that in Middle income?
Provide a short and direct response. 3.14. What is the ratio of the Mineral Rent(as % of GDP) of Oil in Middle East & North Africa (all income levels) to that in Middle income?
Offer a terse response. 5.88. What is the ratio of the Mineral Rent(as % of GDP) of Other Minerals in Middle East & North Africa (all income levels) to that in Middle income?
Make the answer very short. 0.07. What is the ratio of the Mineral Rent(as % of GDP) of Coal in Middle East & North Africa (developing only) to that in Middle income?
Offer a very short reply. 0.03. What is the ratio of the Mineral Rent(as % of GDP) of Natural Gas in Middle East & North Africa (developing only) to that in Middle income?
Offer a very short reply. 3.33. What is the ratio of the Mineral Rent(as % of GDP) in Oil in Middle East & North Africa (developing only) to that in Middle income?
Ensure brevity in your answer.  4.59. What is the ratio of the Mineral Rent(as % of GDP) in Other Minerals in Middle East & North Africa (developing only) to that in Middle income?
Your answer should be very brief. 0.13. What is the difference between the highest and the second highest Mineral Rent(as % of GDP) of Coal?
Keep it short and to the point. 0.06. What is the difference between the highest and the second highest Mineral Rent(as % of GDP) in Natural Gas?
Provide a succinct answer. 0.13. What is the difference between the highest and the second highest Mineral Rent(as % of GDP) in Oil?
Keep it short and to the point. 4.31. What is the difference between the highest and the second highest Mineral Rent(as % of GDP) in Other Minerals?
Ensure brevity in your answer.  0.82. What is the difference between the highest and the lowest Mineral Rent(as % of GDP) of Coal?
Make the answer very short. 0.11. What is the difference between the highest and the lowest Mineral Rent(as % of GDP) of Natural Gas?
Give a very brief answer. 2.27. What is the difference between the highest and the lowest Mineral Rent(as % of GDP) in Oil?
Your answer should be very brief. 19.71. What is the difference between the highest and the lowest Mineral Rent(as % of GDP) of Other Minerals?
Ensure brevity in your answer.  1.11. 